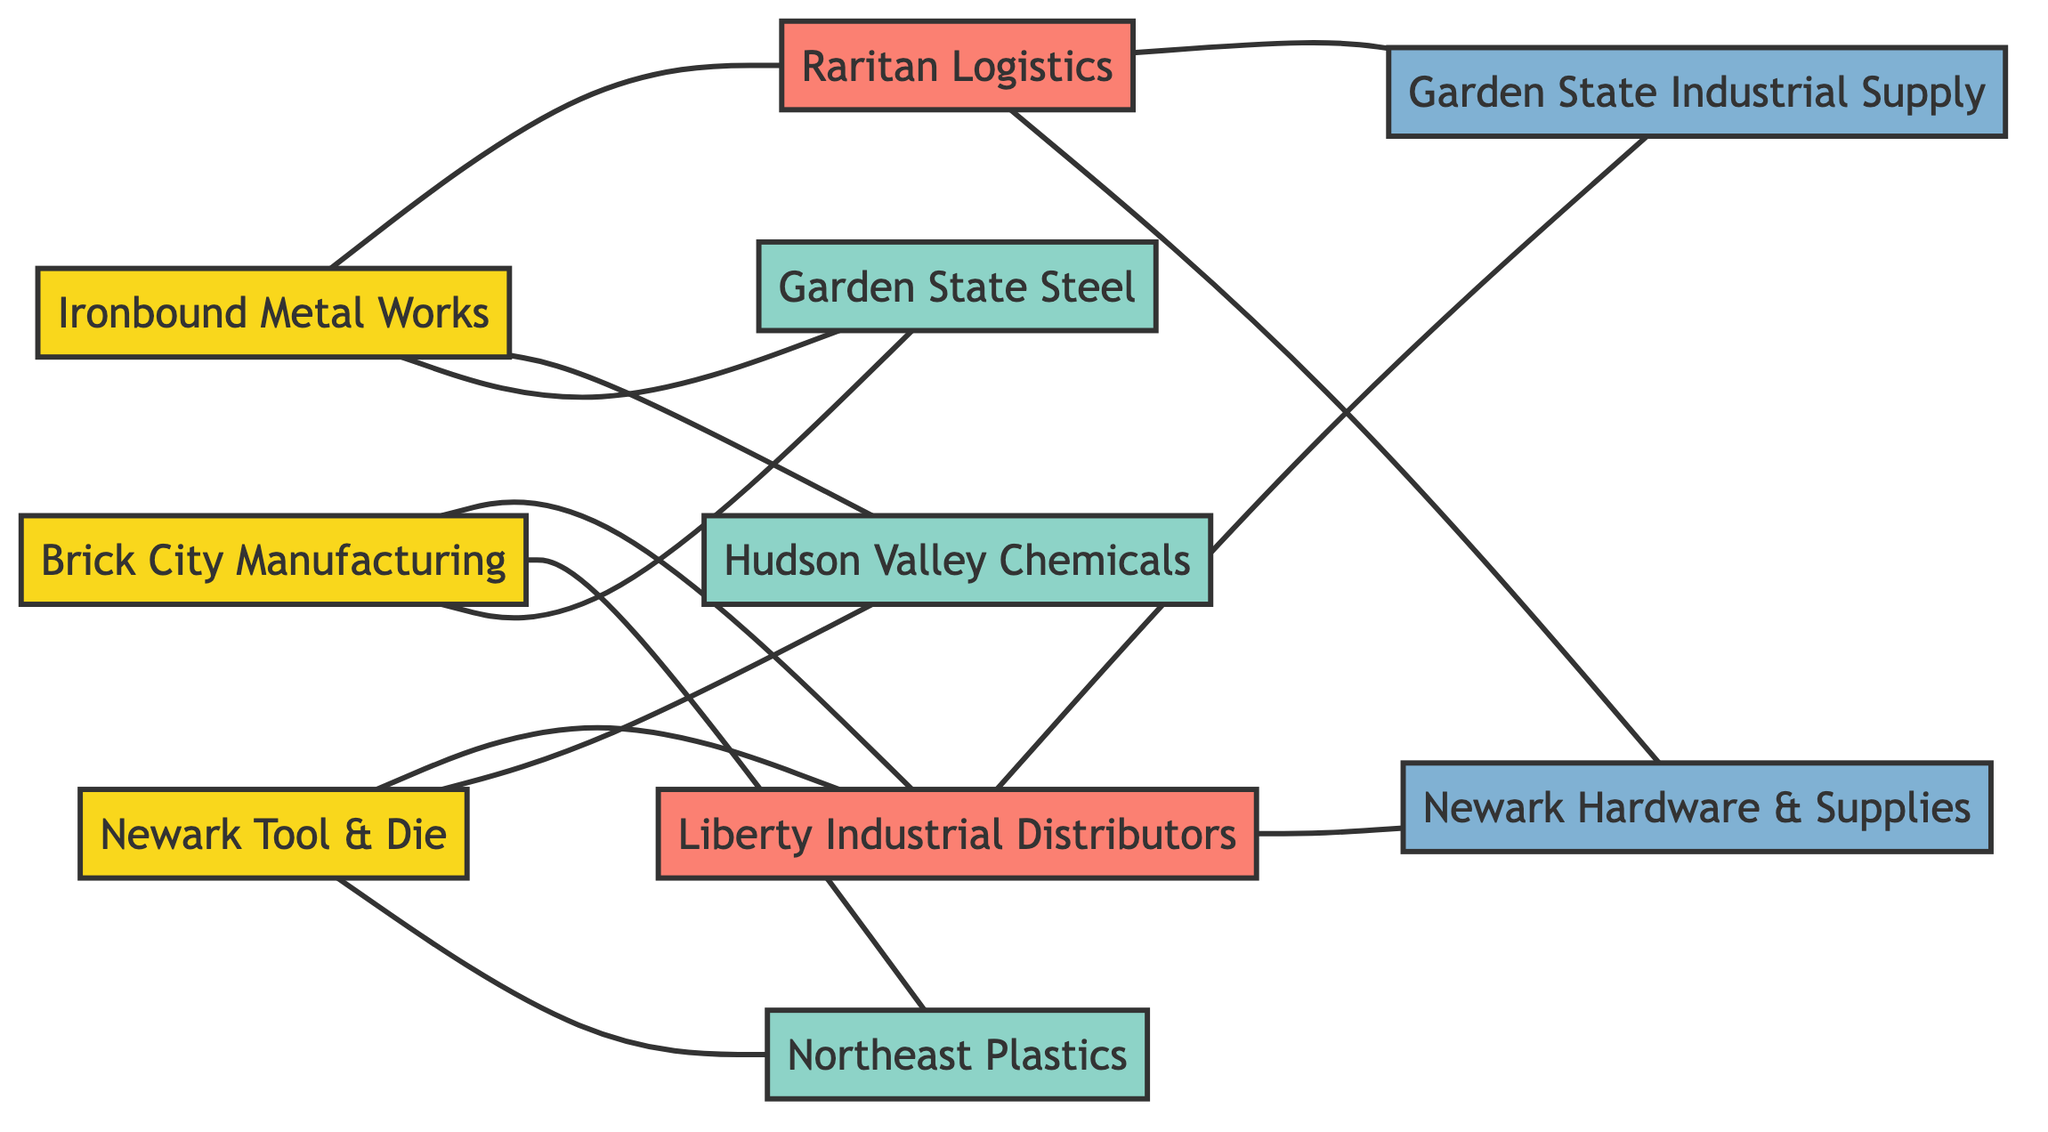What is the total number of businesses depicted in the diagram? The diagram shows three businesses: Brick City Manufacturing, Ironbound Metal Works, and Newark Tool & Die.
Answer: 3 Which distributor is connected to Brick City Manufacturing? Brick City Manufacturing is connected to Liberty Industrial Distributors. By checking the edges, it is identified that only Liberty Industrial Distributors connects directly to Brick City Manufacturing.
Answer: Liberty Industrial Distributors How many suppliers does Ironbound Metal Works have? Ironbound Metal Works is connected to two suppliers: Garden State Steel and Hudson Valley Chemicals, as seen in the edges connecting to these suppliers.
Answer: 2 What is the relationship between Newark Tool & Die and Hudson Valley Chemicals? Newark Tool & Die is connected to Hudson Valley Chemicals, indicating a supply relationship, as shown in the edges.
Answer: Supply relationship Which retailer is connected to both distributors? Newark Hardware & Supplies is connected to both Liberty Industrial Distributors and Raritan Logistics, as evident from the edges connecting these nodes.
Answer: Newark Hardware & Supplies Which business has the most direct connections in the diagram? Brick City Manufacturing has three direct connections (to two suppliers and one distributor) while Ironbound Metal Works and Newark Tool & Die have fewer. Thus, Brick City Manufacturing has the most connections.
Answer: Brick City Manufacturing How many total edges are there in the diagram? By counting the relationships listed in the edges, we find there are 13 edges in total connecting the nodes in the diagram.
Answer: 13 Is there a connection between Newark Tool & Die and any retailer? Newark Tool & Die does not have a direct connection to any retailer; it only connects to suppliers and distributors. Evaluating the edges confirms there are no direct links to retailers from Newark Tool & Die.
Answer: No Which supplier supplies more than one business? The supplier Garden State Steel supplies both Brick City Manufacturing and Ironbound Metal Works, as seen from the diagram.
Answer: Garden State Steel 